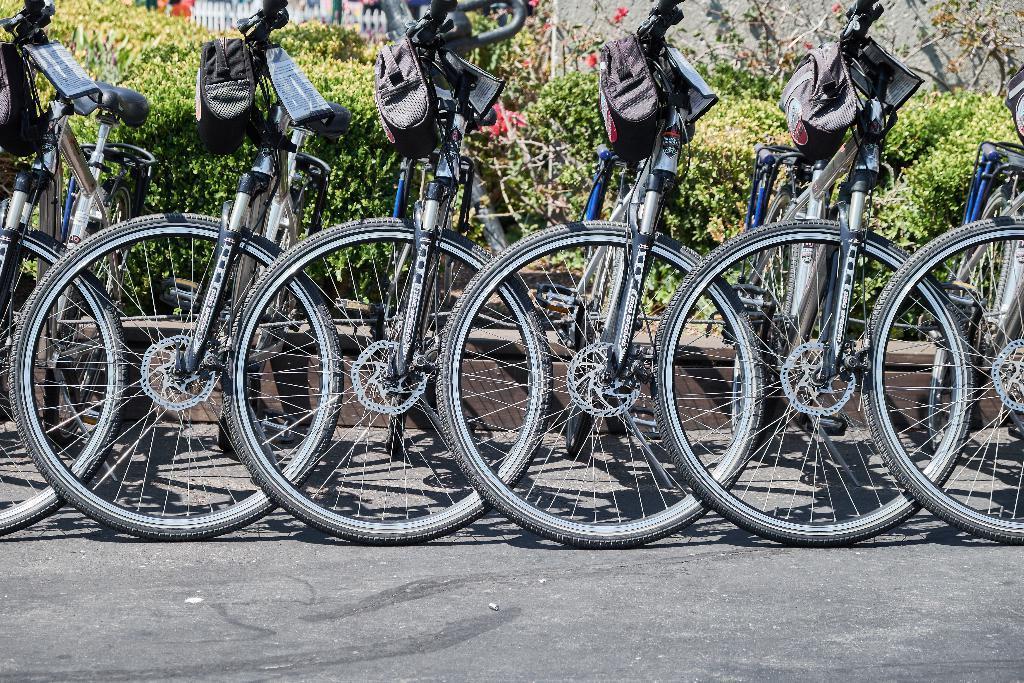Describe this image in one or two sentences. Here we can see some bicycle are parked. Behind there are some plants. 